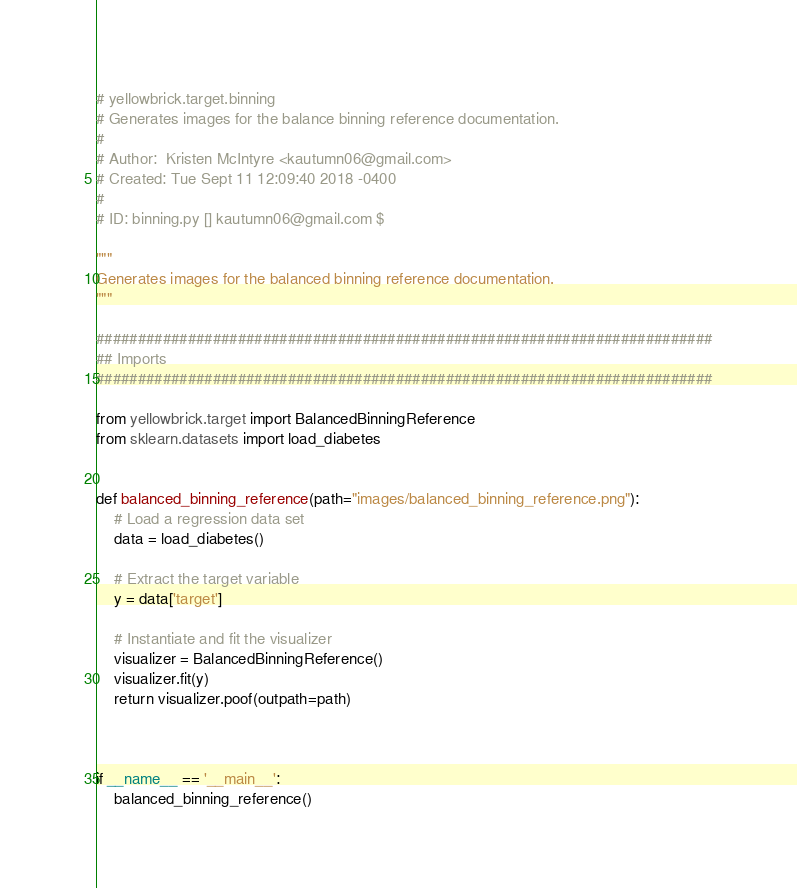Convert code to text. <code><loc_0><loc_0><loc_500><loc_500><_Python_># yellowbrick.target.binning
# Generates images for the balance binning reference documentation.
#
# Author:  Kristen McIntyre <kautumn06@gmail.com>
# Created: Tue Sept 11 12:09:40 2018 -0400
#
# ID: binning.py [] kautumn06@gmail.com $

"""
Generates images for the balanced binning reference documentation.
"""

##########################################################################
## Imports
##########################################################################

from yellowbrick.target import BalancedBinningReference 
from sklearn.datasets import load_diabetes


def balanced_binning_reference(path="images/balanced_binning_reference.png"):
    # Load a regression data set
    data = load_diabetes()

    # Extract the target variable
    y = data['target']

    # Instantiate and fit the visualizer
    visualizer = BalancedBinningReference()
    visualizer.fit(y)
    return visualizer.poof(outpath=path)



if __name__ == '__main__':
    balanced_binning_reference()
</code> 